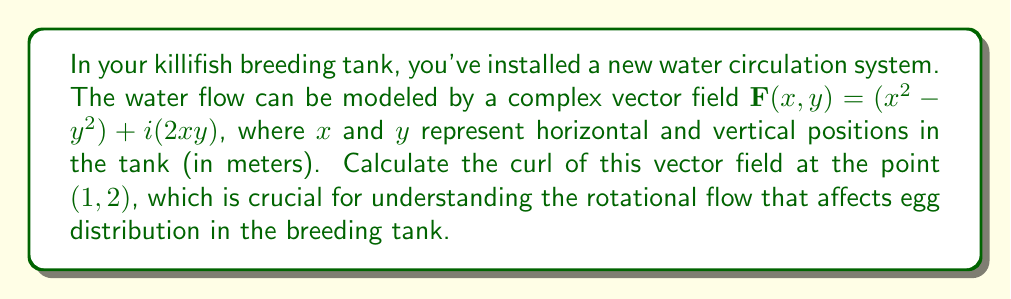Provide a solution to this math problem. To calculate the curl of the complex vector field, we'll follow these steps:

1) For a 2D complex vector field $\mathbf{F}(x,y) = u(x,y) + iv(x,y)$, the curl is defined as:

   $$\text{curl }\mathbf{F} = \frac{\partial v}{\partial x} - \frac{\partial u}{\partial y}$$

2) In our case, $u(x,y) = x^2 - y^2$ and $v(x,y) = 2xy$

3) Calculate $\frac{\partial v}{\partial x}$:
   $$\frac{\partial v}{\partial x} = \frac{\partial (2xy)}{\partial x} = 2y$$

4) Calculate $\frac{\partial u}{\partial y}$:
   $$\frac{\partial u}{\partial y} = \frac{\partial (x^2 - y^2)}{\partial y} = -2y$$

5) Now, we can calculate the curl:
   $$\text{curl }\mathbf{F} = \frac{\partial v}{\partial x} - \frac{\partial u}{\partial y} = 2y - (-2y) = 4y$$

6) At the point $(1,2)$, $y = 2$, so:
   $$\text{curl }\mathbf{F}(1,2) = 4(2) = 8$$

Therefore, the curl of the vector field at $(1,2)$ is 8, indicating a significant rotational flow at this point in the killifish breeding tank.
Answer: 8 